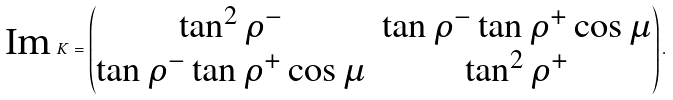<formula> <loc_0><loc_0><loc_500><loc_500>\text {Im\,} K = \begin{pmatrix} \tan ^ { 2 } \rho ^ { - } & \tan \rho ^ { - } \tan \rho ^ { + } \cos \mu \\ \tan \rho ^ { - } \tan \rho ^ { + } \cos \mu & \tan ^ { 2 } \rho ^ { + } \end{pmatrix} .</formula> 